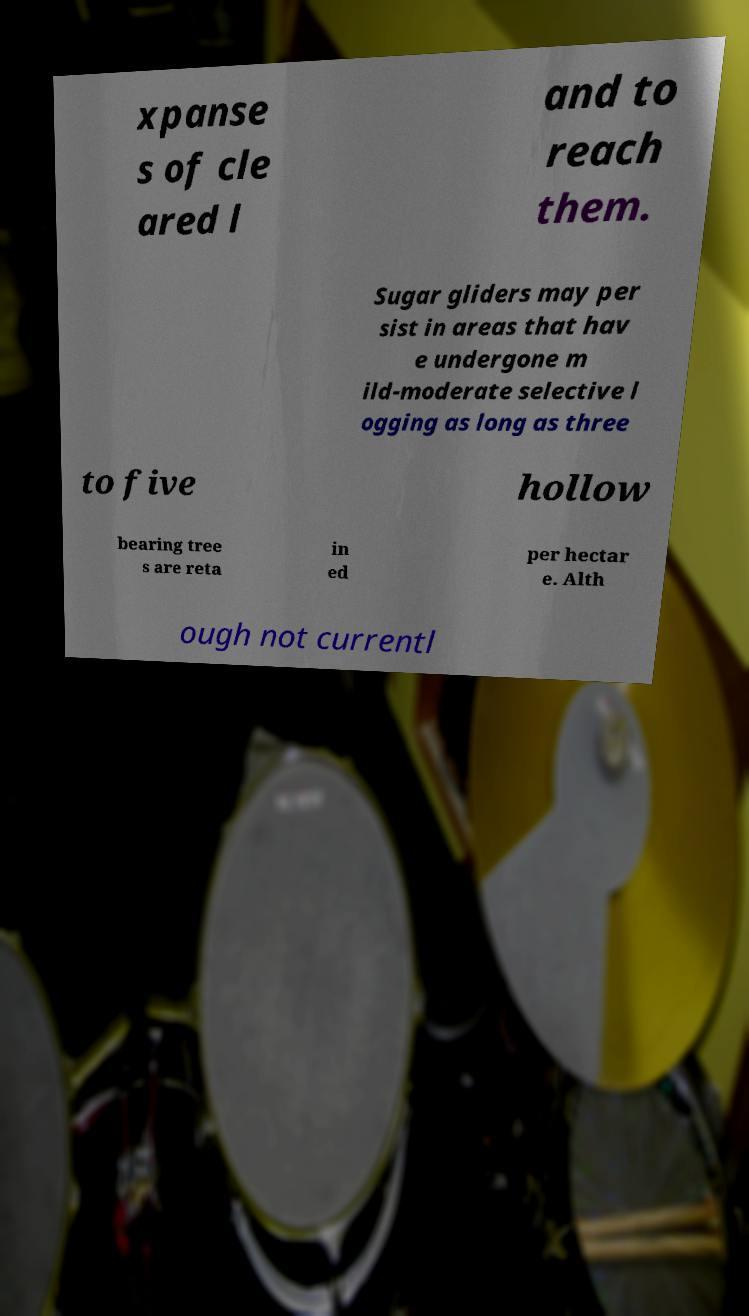For documentation purposes, I need the text within this image transcribed. Could you provide that? xpanse s of cle ared l and to reach them. Sugar gliders may per sist in areas that hav e undergone m ild-moderate selective l ogging as long as three to five hollow bearing tree s are reta in ed per hectar e. Alth ough not currentl 